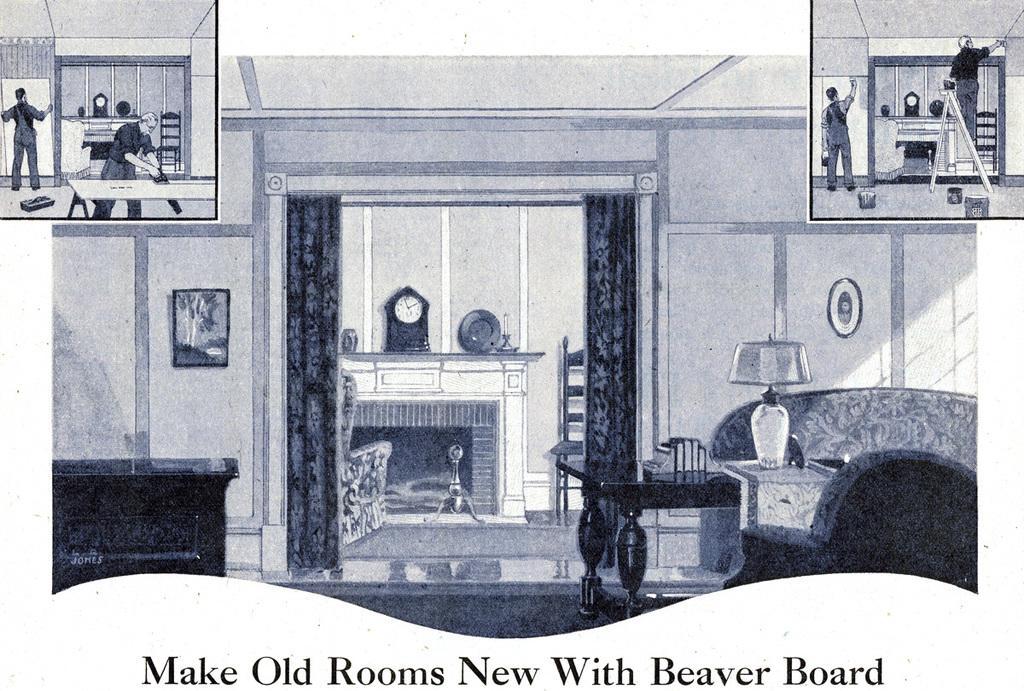Describe this image in one or two sentences. As we can see in the image there is a paper. On paper there is wall, curtains, photo frame, clock, chair, sofa, lamp and tables. 